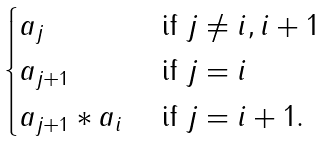Convert formula to latex. <formula><loc_0><loc_0><loc_500><loc_500>\begin{cases} a _ { j } & \text { if $j\neq i,i+1$} \\ a _ { j + 1 } & \text { if $j=i$} \\ a _ { j + 1 } * a _ { i } & \text { if $j=i+1$.} \end{cases}</formula> 